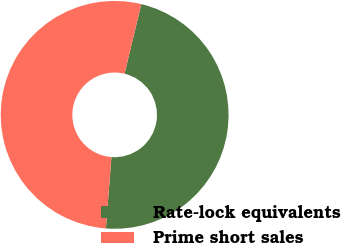<chart> <loc_0><loc_0><loc_500><loc_500><pie_chart><fcel>Rate-lock equivalents<fcel>Prime short sales<nl><fcel>47.47%<fcel>52.53%<nl></chart> 